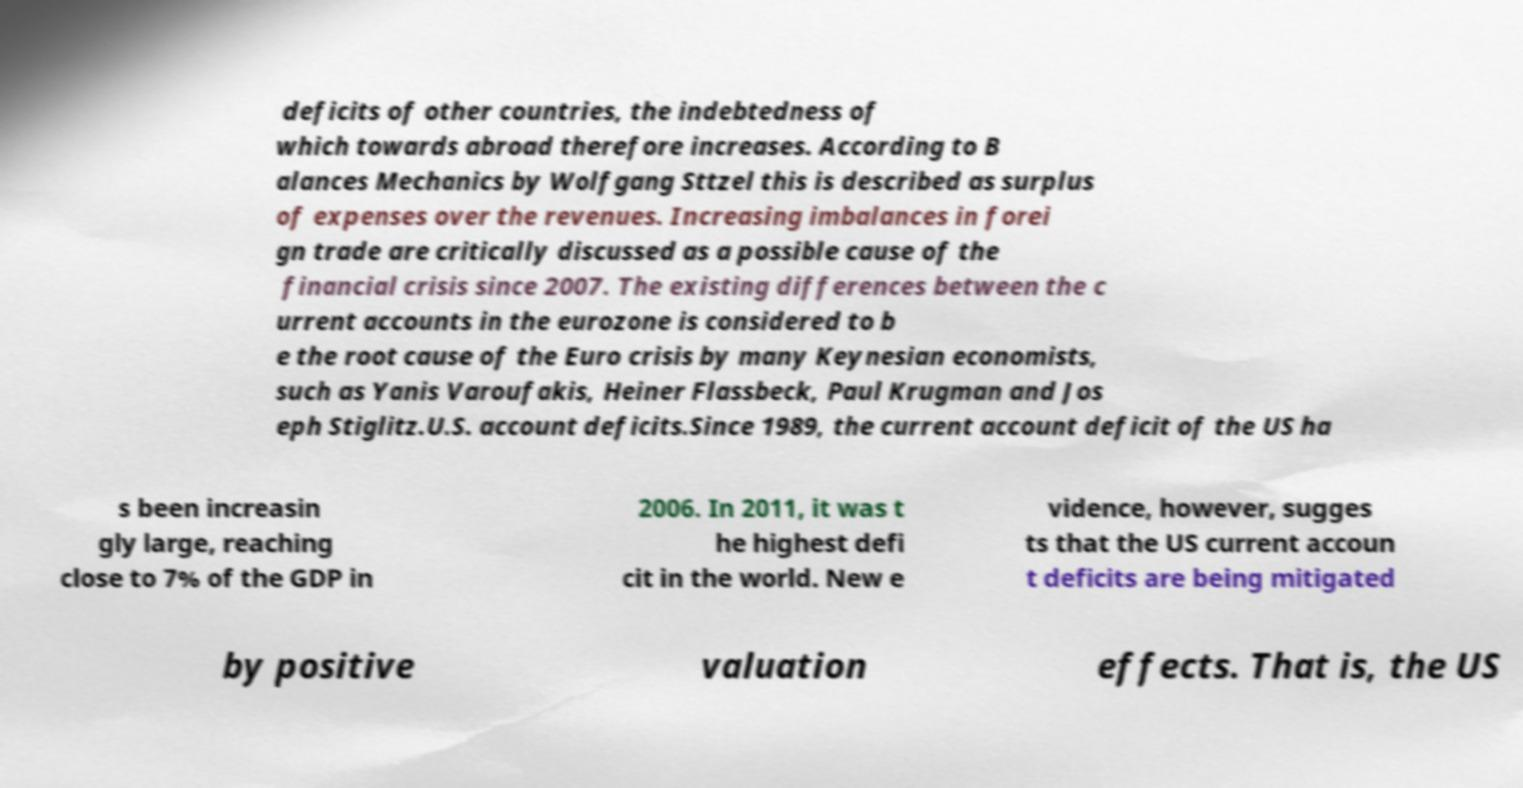Can you read and provide the text displayed in the image?This photo seems to have some interesting text. Can you extract and type it out for me? deficits of other countries, the indebtedness of which towards abroad therefore increases. According to B alances Mechanics by Wolfgang Sttzel this is described as surplus of expenses over the revenues. Increasing imbalances in forei gn trade are critically discussed as a possible cause of the financial crisis since 2007. The existing differences between the c urrent accounts in the eurozone is considered to b e the root cause of the Euro crisis by many Keynesian economists, such as Yanis Varoufakis, Heiner Flassbeck, Paul Krugman and Jos eph Stiglitz.U.S. account deficits.Since 1989, the current account deficit of the US ha s been increasin gly large, reaching close to 7% of the GDP in 2006. In 2011, it was t he highest defi cit in the world. New e vidence, however, sugges ts that the US current accoun t deficits are being mitigated by positive valuation effects. That is, the US 